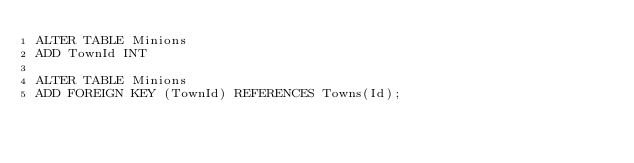<code> <loc_0><loc_0><loc_500><loc_500><_SQL_>ALTER TABLE Minions
ADD TownId INT

ALTER TABLE Minions
ADD FOREIGN KEY (TownId) REFERENCES Towns(Id);</code> 